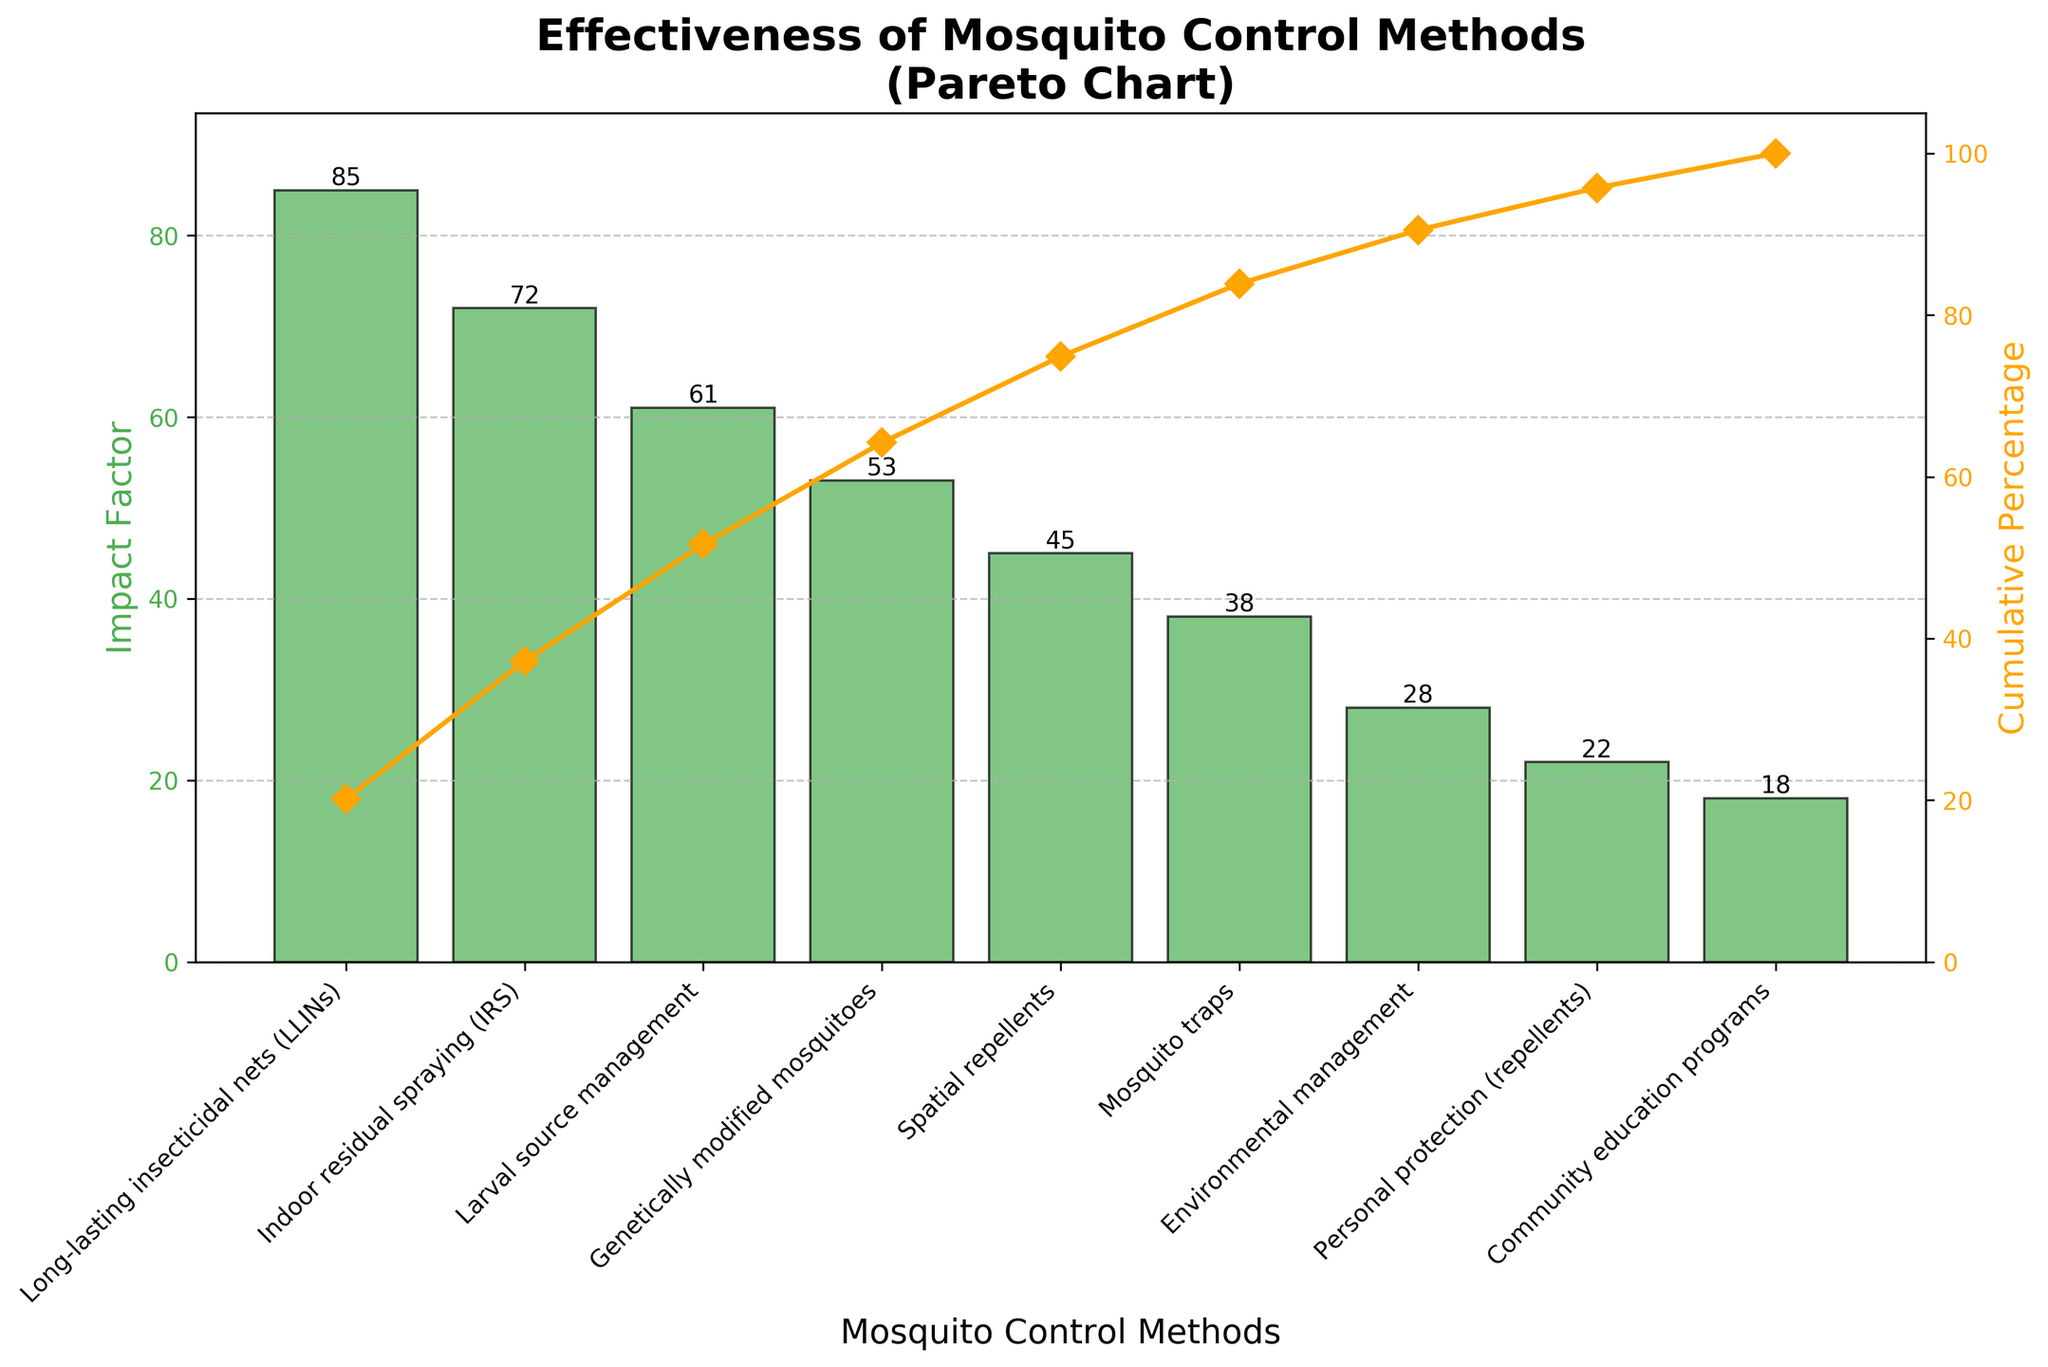What is the title of the figure? The title is usually displayed at the top of the figure and describes what the figure is about. Here, it is clearly shown and easily readable.
Answer: Effectiveness of Mosquito Control Methods (Pareto Chart) Which mosquito control method has the highest impact factor? The method with the highest impact factor is the tallest bar. In this figure, the tallest bar is for "Long-lasting insecticidal nets (LLINs)".
Answer: Long-lasting insecticidal nets (LLINs) What is the cumulative percentage for Indoor residual spraying (IRS)? First, locate the bar for "Indoor residual spraying (IRS)" and then refer to the cumulative percentage line (orange). The cumulative percentage at this point is approximately 157 / 214 * 100 = 73.36%.
Answer: 73.36% How many mosquito control methods are depicted in the chart? To find the number of methods, count the individual bars in the chart. Each bar represents a unique method.
Answer: 9 What is the combined impact factor of the top three mosquito control methods? Add the impact factors of the top three methods: Long-lasting insecticidal nets (LLINs) is 85, Indoor residual spraying (IRS) is 72, and Larval source management is 61. So, 85 + 72 + 61 = 218.
Answer: 218 What is the percentage contribution of "Mosquito traps" to the total impact factor? Determine the total impact factor sum (85+72+61+53+45+38+28+22+18 = 422) and then calculate the percentage contribution of "Mosquito traps" (38). So, (38 / 422) * 100 = 9%.
Answer: 9% Compare the impact factors of "Genetically modified mosquitoes" and "Environmental management". Which one is greater, and by how much? The impact factor of "Genetically modified mosquitoes" is 53 while "Environmental management" is 28. Subtract the lower from the higher to find the difference: 53 - 28 = 25.
Answer: Genetically modified mosquitoes by 25 What is the impact of "Personal protection (repellents)" in reducing disease transmission? Locate “Personal protection (repellents)” on the x-axis and refer to the height of its bar showing its impact factor, which is 22.
Answer: 22 Which mosquito control method is ranked last in terms of impact factor? The last rank indicates the smallest bar in the figure. Here, the "Community education programs" has the smallest impact factor.
Answer: Community education programs 